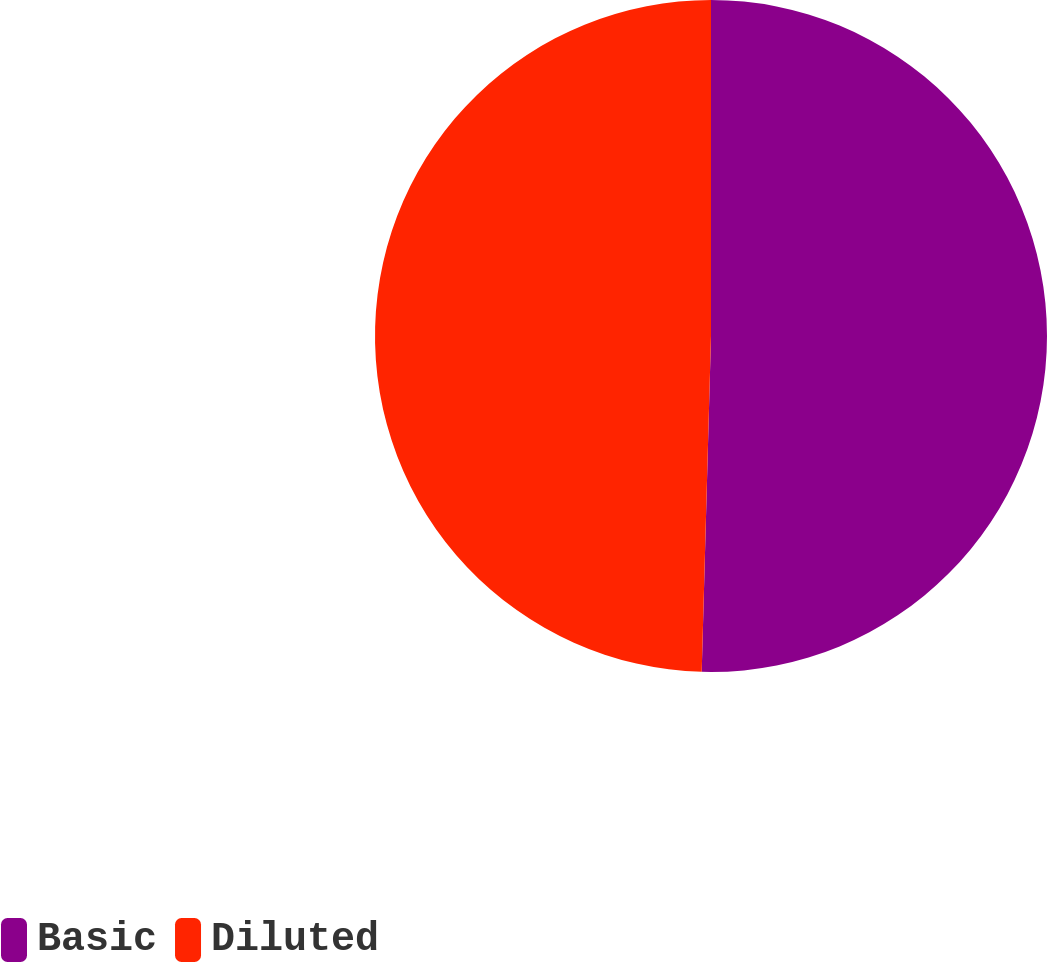Convert chart. <chart><loc_0><loc_0><loc_500><loc_500><pie_chart><fcel>Basic<fcel>Diluted<nl><fcel>50.44%<fcel>49.56%<nl></chart> 